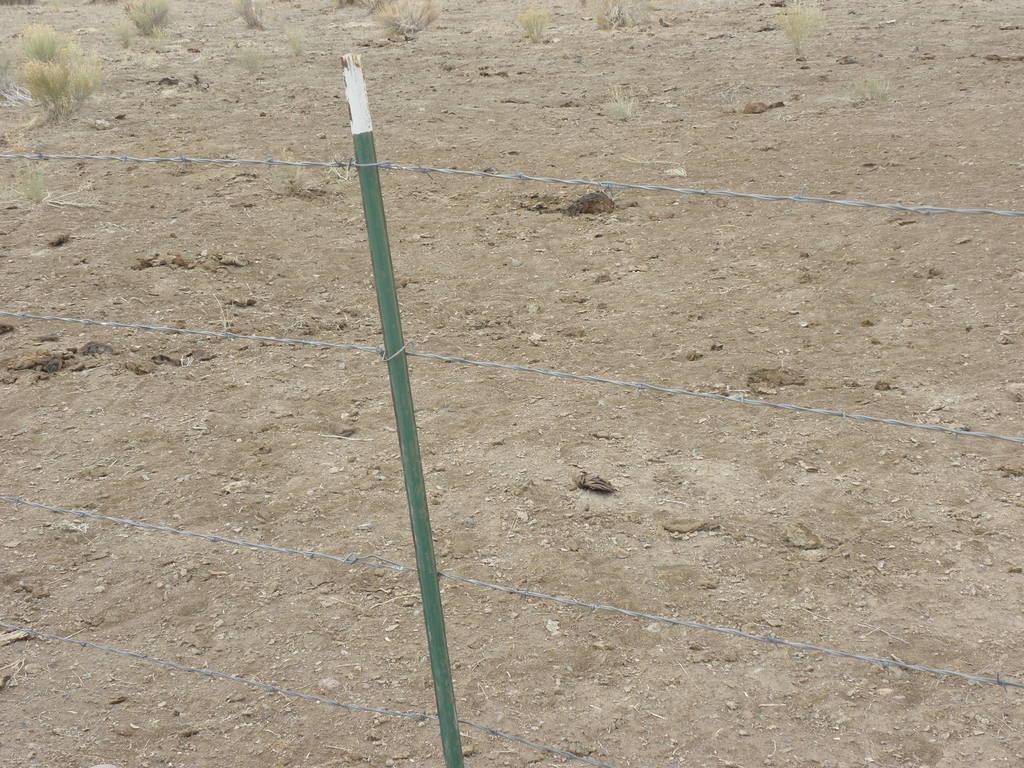Can you describe this image briefly? In this image we can see a fence. In the background there is grass. 